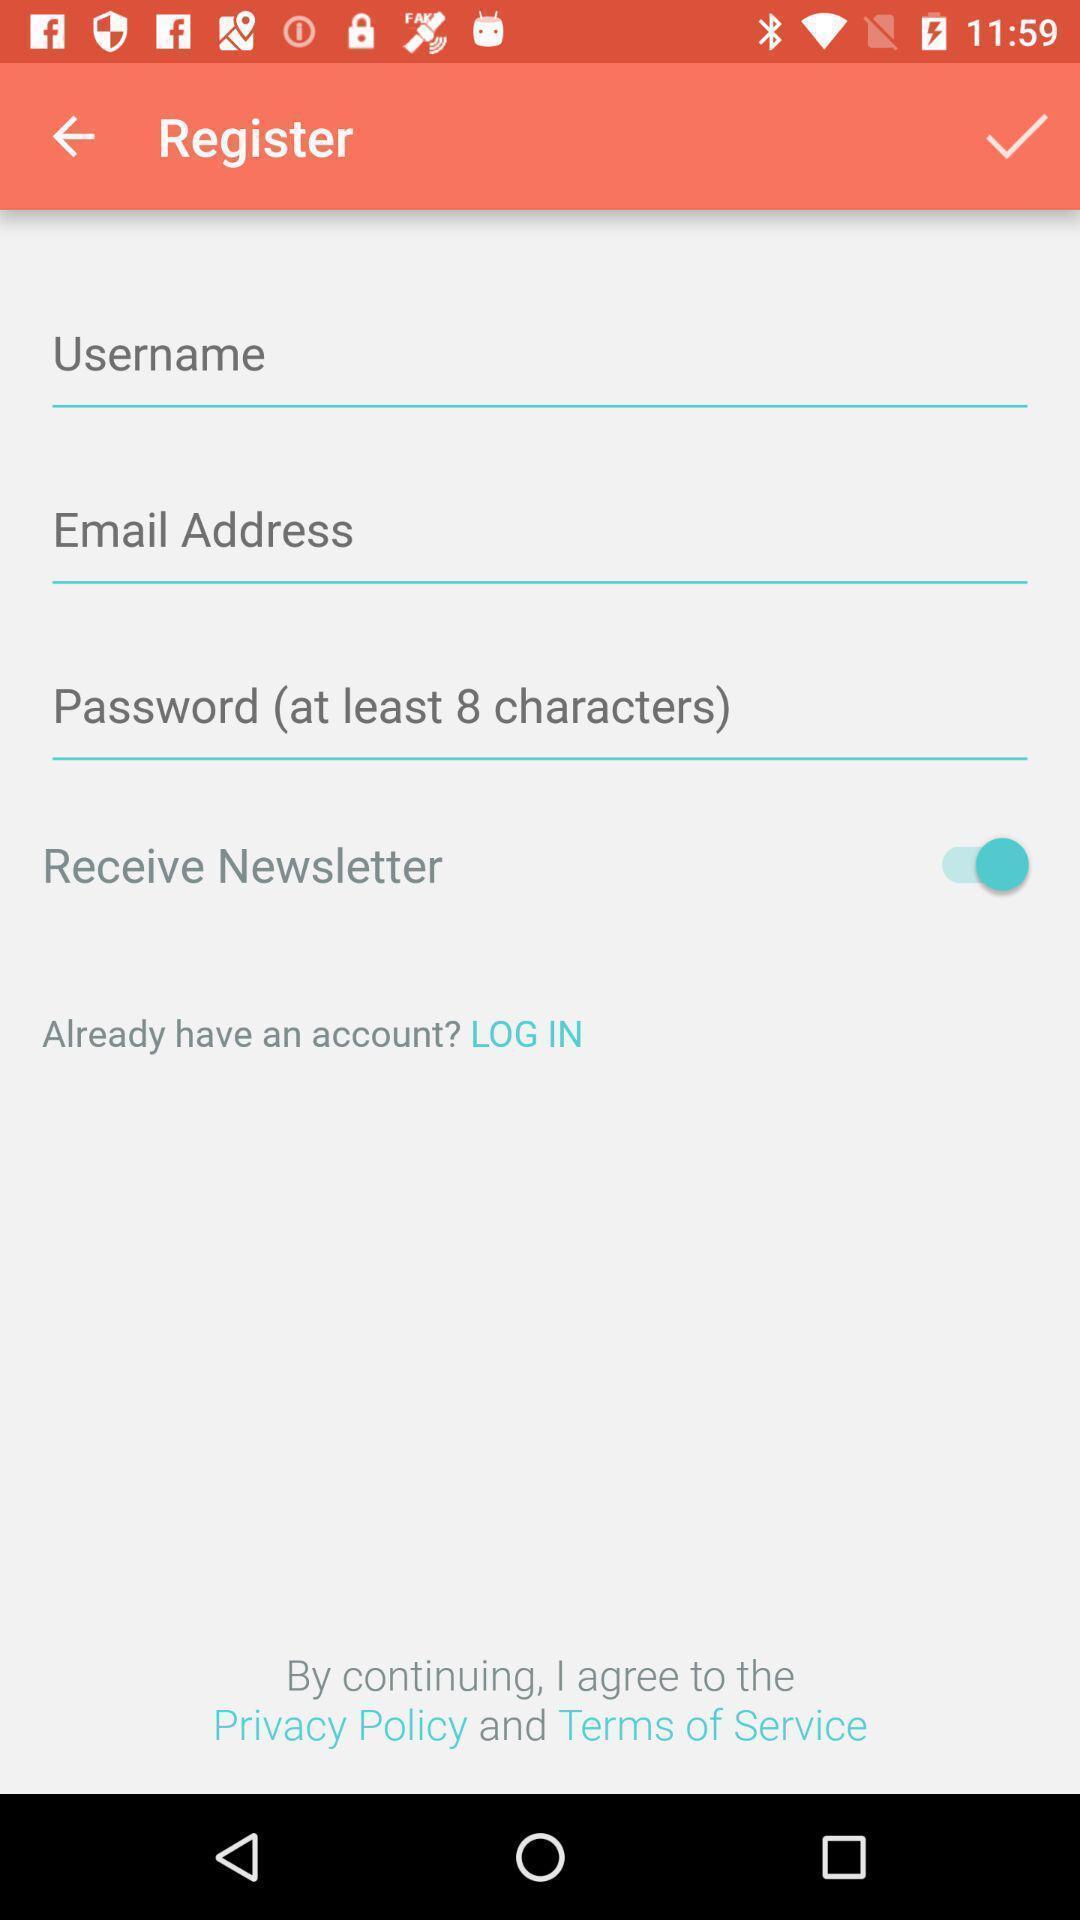Give me a narrative description of this picture. Screen displaying the register page. 